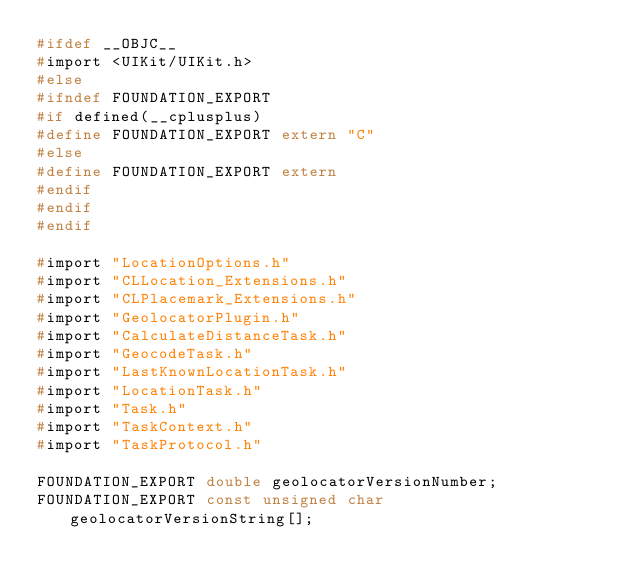<code> <loc_0><loc_0><loc_500><loc_500><_C_>#ifdef __OBJC__
#import <UIKit/UIKit.h>
#else
#ifndef FOUNDATION_EXPORT
#if defined(__cplusplus)
#define FOUNDATION_EXPORT extern "C"
#else
#define FOUNDATION_EXPORT extern
#endif
#endif
#endif

#import "LocationOptions.h"
#import "CLLocation_Extensions.h"
#import "CLPlacemark_Extensions.h"
#import "GeolocatorPlugin.h"
#import "CalculateDistanceTask.h"
#import "GeocodeTask.h"
#import "LastKnownLocationTask.h"
#import "LocationTask.h"
#import "Task.h"
#import "TaskContext.h"
#import "TaskProtocol.h"

FOUNDATION_EXPORT double geolocatorVersionNumber;
FOUNDATION_EXPORT const unsigned char geolocatorVersionString[];

</code> 